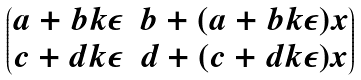<formula> <loc_0><loc_0><loc_500><loc_500>\begin{pmatrix} a + b k \epsilon & b + ( a + b k \epsilon ) x \\ c + d k \epsilon & d + ( c + d k \epsilon ) x \end{pmatrix}</formula> 